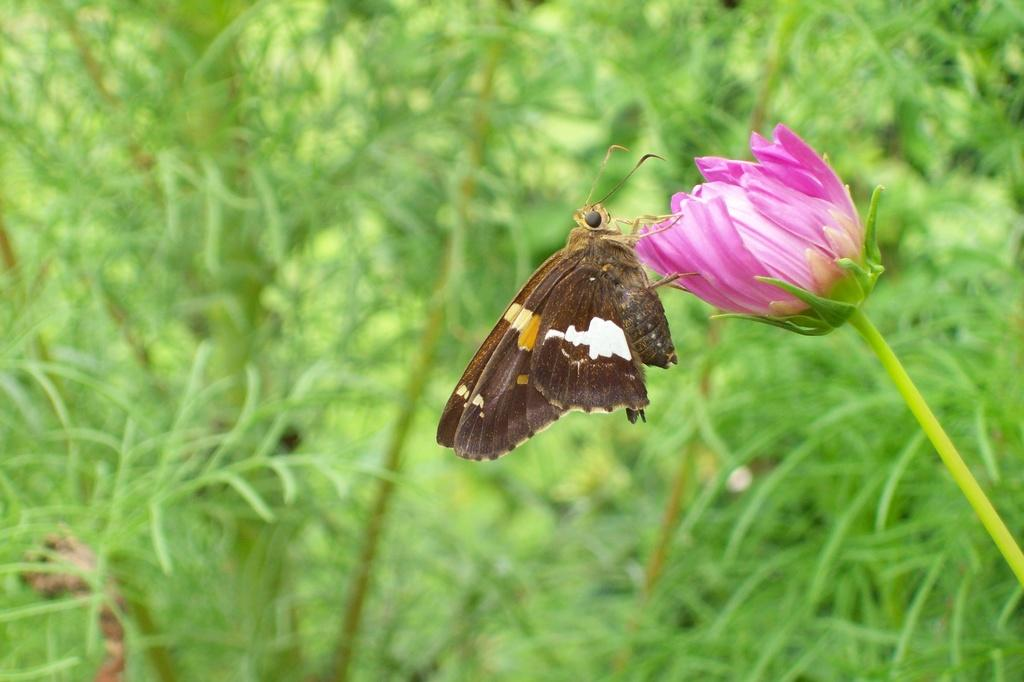What type of living organisms are present in the image? There is a group of plants in the image. What specific feature can be observed about the flowers on the plants? The flowers have pink stems. What other creature can be seen in the image besides the plants? There is a butterfly in the image. What is the color of the butterfly? The butterfly is brown in color. What type of jewel can be seen on the butterfly's wing in the image? There is no jewel present on the butterfly's wing in the image. What is the visibility like in the image due to the presence of fog? There is no fog present in the image, so it cannot affect the visibility. 